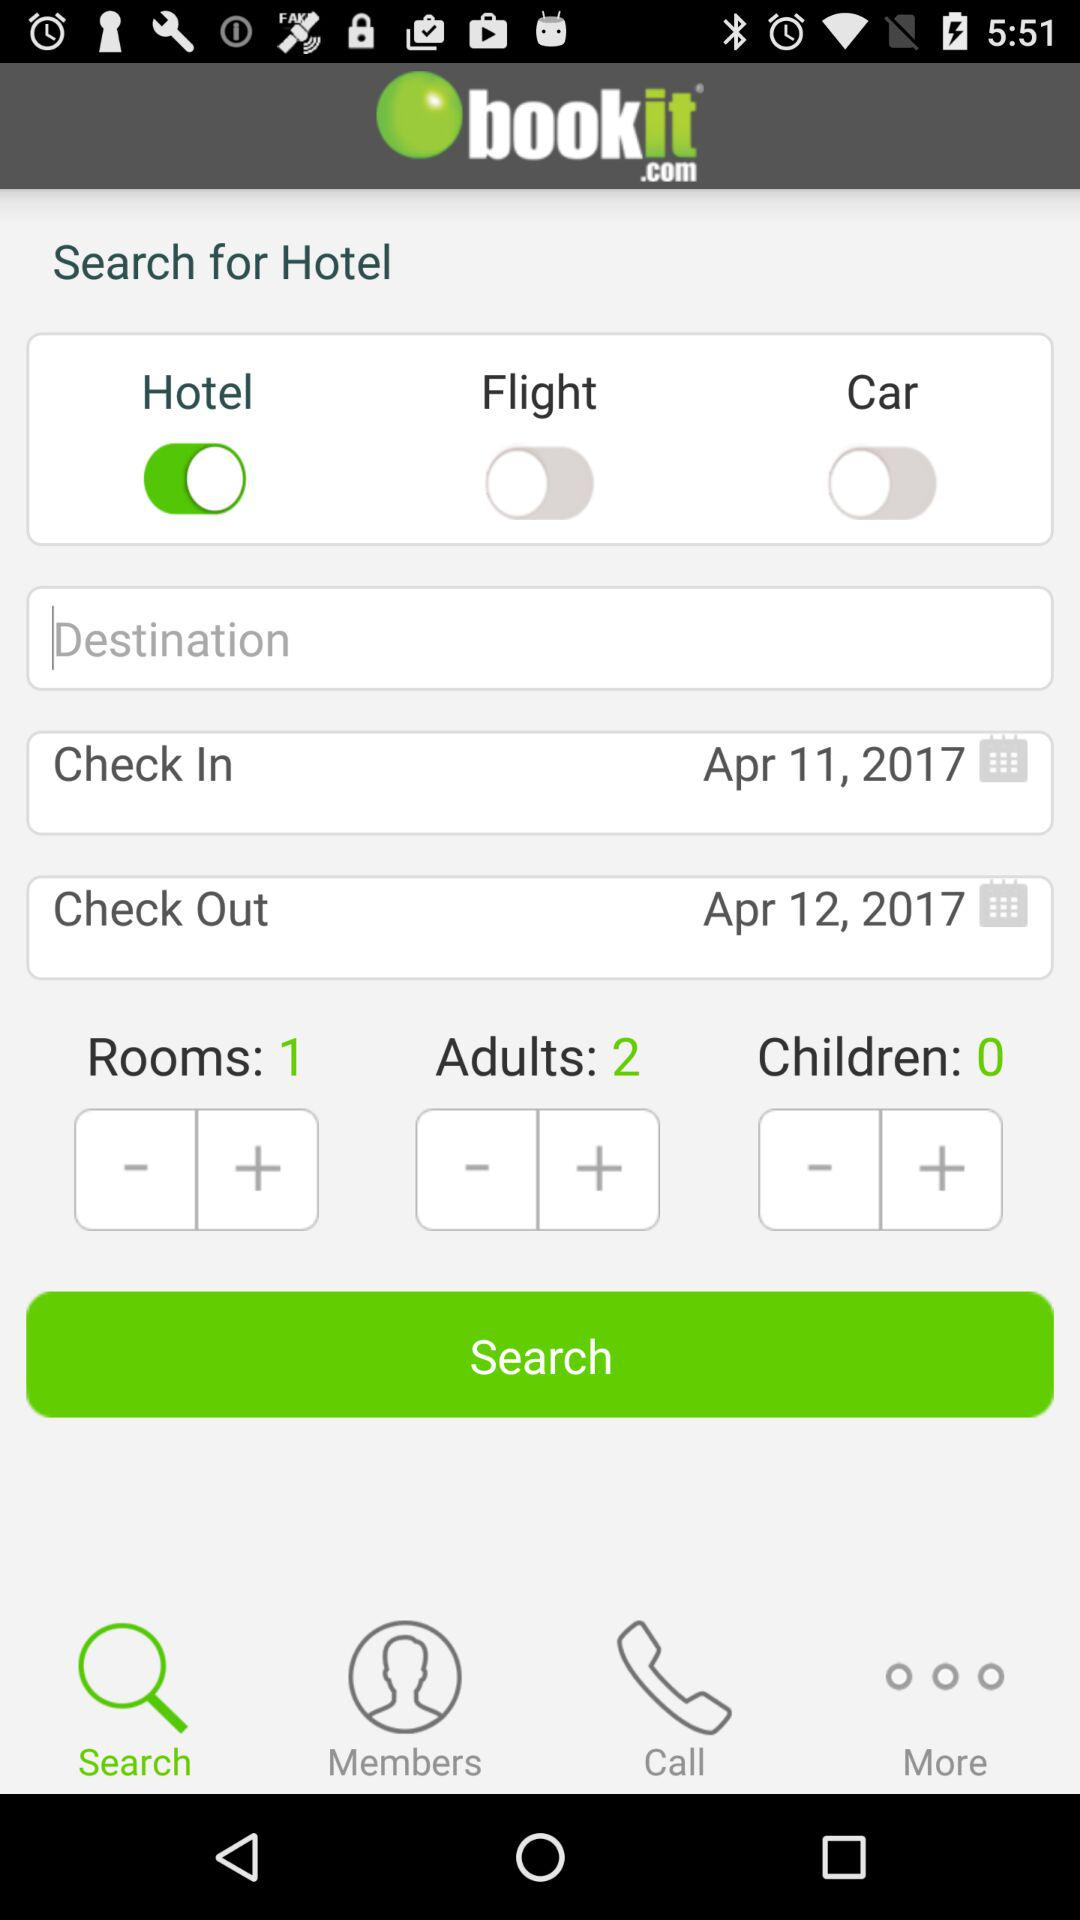What is the status of "Car"? The status is "off". 